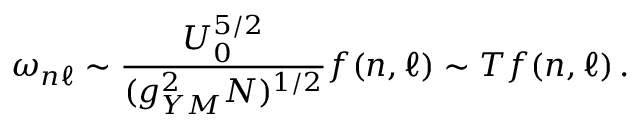Convert formula to latex. <formula><loc_0><loc_0><loc_500><loc_500>\omega _ { n \ell } \sim { \frac { U _ { 0 } ^ { 5 / 2 } } { ( g _ { Y M } ^ { 2 } N ) ^ { 1 / 2 } } } f ( n , \ell ) \sim T f ( n , \ell ) \, .</formula> 